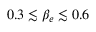<formula> <loc_0><loc_0><loc_500><loc_500>0 . 3 \lesssim \beta _ { e } \lesssim 0 . 6</formula> 